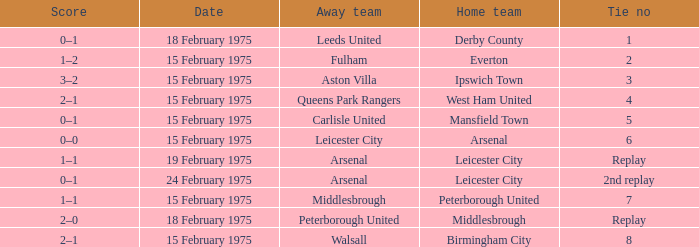What was the date when the away team was carlisle united? 15 February 1975. Would you be able to parse every entry in this table? {'header': ['Score', 'Date', 'Away team', 'Home team', 'Tie no'], 'rows': [['0–1', '18 February 1975', 'Leeds United', 'Derby County', '1'], ['1–2', '15 February 1975', 'Fulham', 'Everton', '2'], ['3–2', '15 February 1975', 'Aston Villa', 'Ipswich Town', '3'], ['2–1', '15 February 1975', 'Queens Park Rangers', 'West Ham United', '4'], ['0–1', '15 February 1975', 'Carlisle United', 'Mansfield Town', '5'], ['0–0', '15 February 1975', 'Leicester City', 'Arsenal', '6'], ['1–1', '19 February 1975', 'Arsenal', 'Leicester City', 'Replay'], ['0–1', '24 February 1975', 'Arsenal', 'Leicester City', '2nd replay'], ['1–1', '15 February 1975', 'Middlesbrough', 'Peterborough United', '7'], ['2–0', '18 February 1975', 'Peterborough United', 'Middlesbrough', 'Replay'], ['2–1', '15 February 1975', 'Walsall', 'Birmingham City', '8']]} 